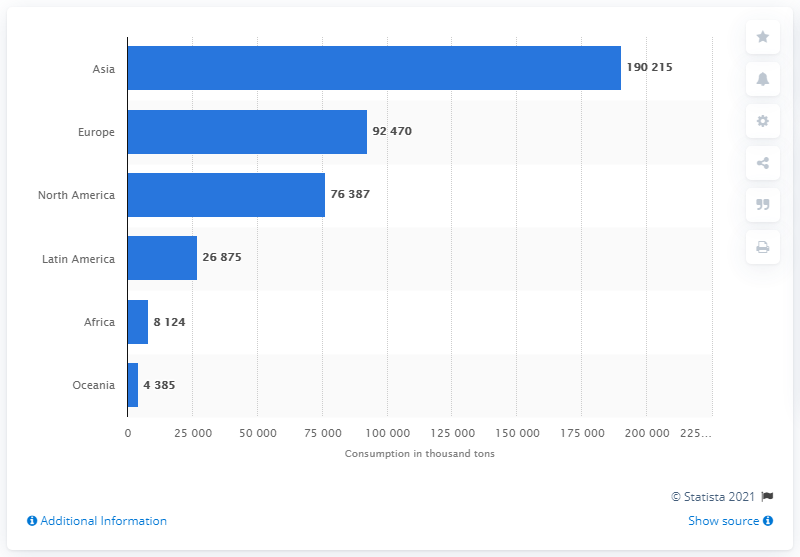Mention a couple of crucial points in this snapshot. In 2016, Europe was the second largest paper consumer in the world. In 2016, a total of 190.22 million tons of paper were consumed globally, with the majority of that consumption occurring in Asia. Europe has a consumption of 92,470. The sum value of the region of North America and Africa is 84,511. 